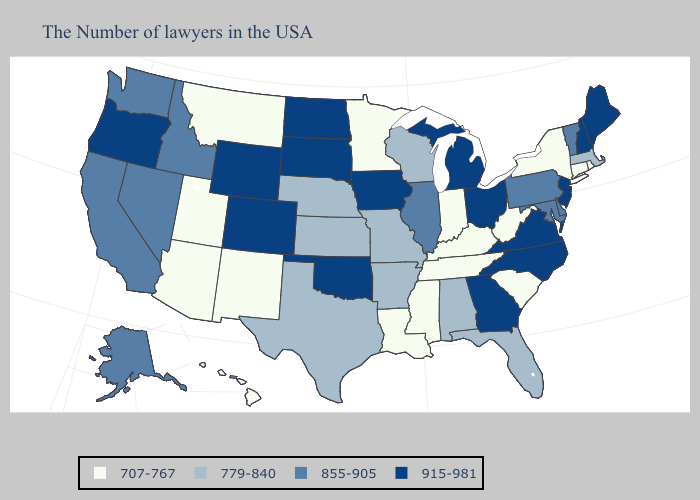Does Minnesota have the lowest value in the MidWest?
Answer briefly. Yes. Does Georgia have the highest value in the South?
Concise answer only. Yes. Does Louisiana have the highest value in the South?
Short answer required. No. Does Mississippi have the lowest value in the South?
Answer briefly. Yes. Among the states that border Massachusetts , which have the lowest value?
Keep it brief. Rhode Island, Connecticut, New York. What is the highest value in the Northeast ?
Short answer required. 915-981. What is the highest value in the USA?
Quick response, please. 915-981. Does Wyoming have the highest value in the West?
Concise answer only. Yes. Does the first symbol in the legend represent the smallest category?
Be succinct. Yes. What is the lowest value in the USA?
Short answer required. 707-767. What is the value of Oklahoma?
Write a very short answer. 915-981. Name the states that have a value in the range 855-905?
Be succinct. Vermont, Delaware, Maryland, Pennsylvania, Illinois, Idaho, Nevada, California, Washington, Alaska. How many symbols are there in the legend?
Quick response, please. 4. Which states have the lowest value in the MidWest?
Be succinct. Indiana, Minnesota. 